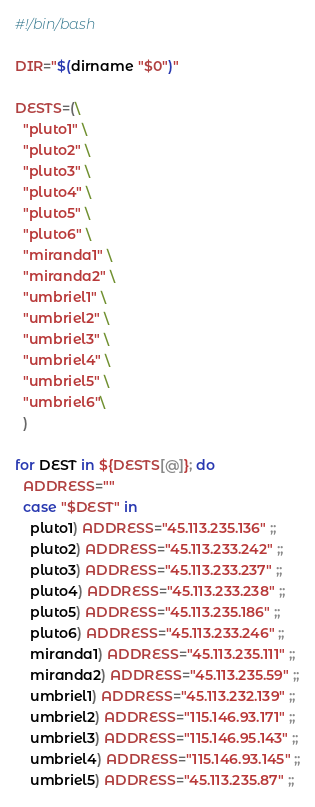<code> <loc_0><loc_0><loc_500><loc_500><_Bash_>#!/bin/bash

DIR="$(dirname "$0")"

DESTS=(\
  "pluto1" \
  "pluto2" \
  "pluto3" \
  "pluto4" \
  "pluto5" \
  "pluto6" \
  "miranda1" \
  "miranda2" \
  "umbriel1" \
  "umbriel2" \
  "umbriel3" \
  "umbriel4" \
  "umbriel5" \
  "umbriel6"\
  )

for DEST in ${DESTS[@]}; do
  ADDRESS=""
  case "$DEST" in
    pluto1) ADDRESS="45.113.235.136" ;;
    pluto2) ADDRESS="45.113.233.242" ;;
    pluto3) ADDRESS="45.113.233.237" ;;
    pluto4) ADDRESS="45.113.233.238" ;;
    pluto5) ADDRESS="45.113.235.186" ;;
    pluto6) ADDRESS="45.113.233.246" ;;
    miranda1) ADDRESS="45.113.235.111" ;;
    miranda2) ADDRESS="45.113.235.59" ;;
    umbriel1) ADDRESS="45.113.232.139" ;;
    umbriel2) ADDRESS="115.146.93.171" ;;
    umbriel3) ADDRESS="115.146.95.143" ;;
    umbriel4) ADDRESS="115.146.93.145" ;;
    umbriel5) ADDRESS="45.113.235.87" ;;</code> 